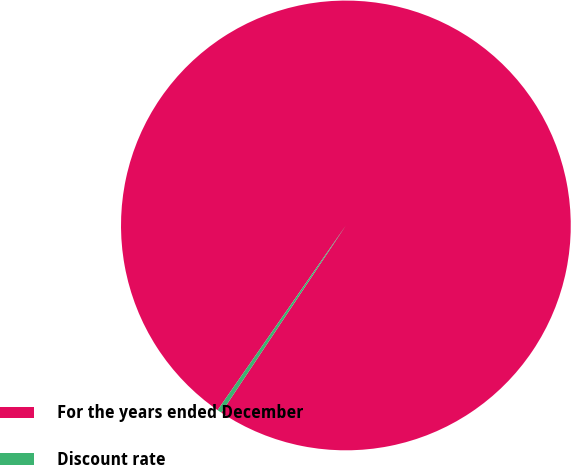Convert chart to OTSL. <chart><loc_0><loc_0><loc_500><loc_500><pie_chart><fcel>For the years ended December<fcel>Discount rate<nl><fcel>99.68%<fcel>0.32%<nl></chart> 